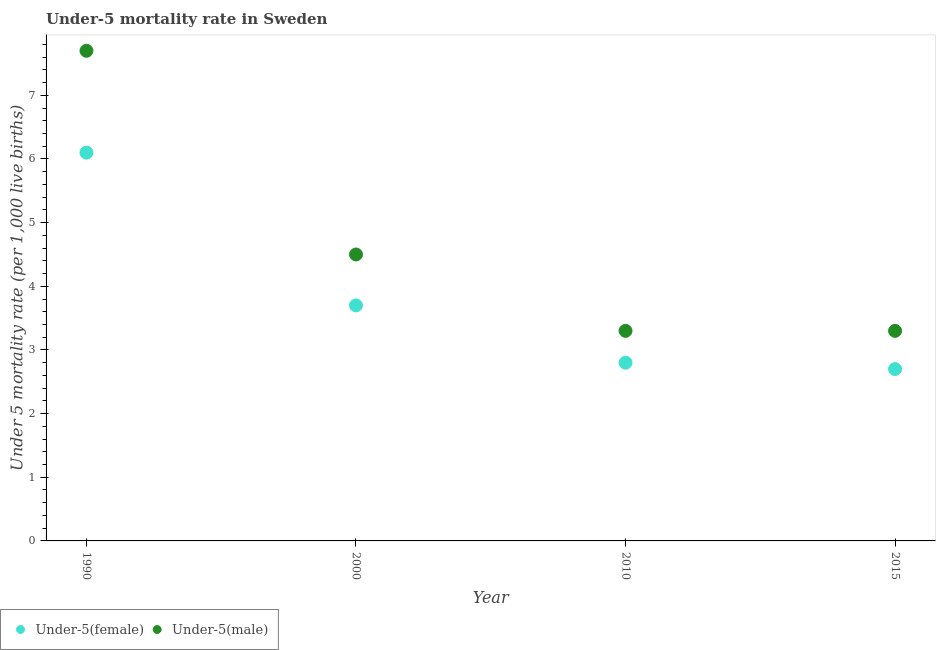Is the number of dotlines equal to the number of legend labels?
Offer a very short reply. Yes. What is the under-5 male mortality rate in 2010?
Provide a succinct answer. 3.3. In which year was the under-5 female mortality rate minimum?
Give a very brief answer. 2015. What is the total under-5 male mortality rate in the graph?
Make the answer very short. 18.8. What is the difference between the under-5 female mortality rate in 2000 and that in 2015?
Give a very brief answer. 1. What is the difference between the under-5 female mortality rate in 2010 and the under-5 male mortality rate in 2015?
Your answer should be compact. -0.5. In the year 2010, what is the difference between the under-5 male mortality rate and under-5 female mortality rate?
Offer a terse response. 0.5. In how many years, is the under-5 female mortality rate greater than 5.8?
Provide a short and direct response. 1. What is the ratio of the under-5 male mortality rate in 1990 to that in 2000?
Make the answer very short. 1.71. Is the under-5 female mortality rate in 2000 less than that in 2015?
Your answer should be compact. No. Is the difference between the under-5 female mortality rate in 2010 and 2015 greater than the difference between the under-5 male mortality rate in 2010 and 2015?
Your answer should be very brief. Yes. What is the difference between the highest and the second highest under-5 male mortality rate?
Your response must be concise. 3.2. What is the difference between the highest and the lowest under-5 female mortality rate?
Give a very brief answer. 3.4. Is the sum of the under-5 male mortality rate in 2000 and 2015 greater than the maximum under-5 female mortality rate across all years?
Your answer should be very brief. Yes. Is the under-5 male mortality rate strictly greater than the under-5 female mortality rate over the years?
Offer a very short reply. Yes. How many dotlines are there?
Offer a very short reply. 2. Does the graph contain any zero values?
Your answer should be compact. No. Does the graph contain grids?
Your answer should be very brief. No. Where does the legend appear in the graph?
Provide a succinct answer. Bottom left. How are the legend labels stacked?
Your answer should be very brief. Horizontal. What is the title of the graph?
Ensure brevity in your answer.  Under-5 mortality rate in Sweden. Does "Excluding technical cooperation" appear as one of the legend labels in the graph?
Ensure brevity in your answer.  No. What is the label or title of the X-axis?
Offer a very short reply. Year. What is the label or title of the Y-axis?
Provide a short and direct response. Under 5 mortality rate (per 1,0 live births). What is the Under 5 mortality rate (per 1,000 live births) in Under-5(female) in 1990?
Give a very brief answer. 6.1. What is the Under 5 mortality rate (per 1,000 live births) in Under-5(female) in 2000?
Offer a very short reply. 3.7. What is the Under 5 mortality rate (per 1,000 live births) in Under-5(male) in 2010?
Provide a succinct answer. 3.3. Across all years, what is the maximum Under 5 mortality rate (per 1,000 live births) in Under-5(female)?
Your answer should be compact. 6.1. What is the difference between the Under 5 mortality rate (per 1,000 live births) in Under-5(female) in 1990 and that in 2010?
Give a very brief answer. 3.3. What is the difference between the Under 5 mortality rate (per 1,000 live births) of Under-5(female) in 1990 and that in 2015?
Provide a short and direct response. 3.4. What is the difference between the Under 5 mortality rate (per 1,000 live births) in Under-5(male) in 2000 and that in 2010?
Offer a very short reply. 1.2. What is the difference between the Under 5 mortality rate (per 1,000 live births) of Under-5(female) in 2000 and that in 2015?
Your answer should be compact. 1. What is the difference between the Under 5 mortality rate (per 1,000 live births) of Under-5(female) in 2000 and the Under 5 mortality rate (per 1,000 live births) of Under-5(male) in 2010?
Provide a succinct answer. 0.4. What is the difference between the Under 5 mortality rate (per 1,000 live births) of Under-5(female) in 2010 and the Under 5 mortality rate (per 1,000 live births) of Under-5(male) in 2015?
Your answer should be compact. -0.5. What is the average Under 5 mortality rate (per 1,000 live births) in Under-5(female) per year?
Offer a very short reply. 3.83. What is the average Under 5 mortality rate (per 1,000 live births) in Under-5(male) per year?
Your answer should be compact. 4.7. In the year 1990, what is the difference between the Under 5 mortality rate (per 1,000 live births) in Under-5(female) and Under 5 mortality rate (per 1,000 live births) in Under-5(male)?
Provide a succinct answer. -1.6. In the year 2010, what is the difference between the Under 5 mortality rate (per 1,000 live births) of Under-5(female) and Under 5 mortality rate (per 1,000 live births) of Under-5(male)?
Your answer should be compact. -0.5. In the year 2015, what is the difference between the Under 5 mortality rate (per 1,000 live births) of Under-5(female) and Under 5 mortality rate (per 1,000 live births) of Under-5(male)?
Keep it short and to the point. -0.6. What is the ratio of the Under 5 mortality rate (per 1,000 live births) in Under-5(female) in 1990 to that in 2000?
Provide a short and direct response. 1.65. What is the ratio of the Under 5 mortality rate (per 1,000 live births) of Under-5(male) in 1990 to that in 2000?
Your response must be concise. 1.71. What is the ratio of the Under 5 mortality rate (per 1,000 live births) of Under-5(female) in 1990 to that in 2010?
Provide a short and direct response. 2.18. What is the ratio of the Under 5 mortality rate (per 1,000 live births) of Under-5(male) in 1990 to that in 2010?
Make the answer very short. 2.33. What is the ratio of the Under 5 mortality rate (per 1,000 live births) of Under-5(female) in 1990 to that in 2015?
Your answer should be very brief. 2.26. What is the ratio of the Under 5 mortality rate (per 1,000 live births) in Under-5(male) in 1990 to that in 2015?
Your answer should be compact. 2.33. What is the ratio of the Under 5 mortality rate (per 1,000 live births) in Under-5(female) in 2000 to that in 2010?
Ensure brevity in your answer.  1.32. What is the ratio of the Under 5 mortality rate (per 1,000 live births) of Under-5(male) in 2000 to that in 2010?
Ensure brevity in your answer.  1.36. What is the ratio of the Under 5 mortality rate (per 1,000 live births) of Under-5(female) in 2000 to that in 2015?
Make the answer very short. 1.37. What is the ratio of the Under 5 mortality rate (per 1,000 live births) of Under-5(male) in 2000 to that in 2015?
Offer a very short reply. 1.36. What is the ratio of the Under 5 mortality rate (per 1,000 live births) in Under-5(female) in 2010 to that in 2015?
Offer a very short reply. 1.04. What is the ratio of the Under 5 mortality rate (per 1,000 live births) of Under-5(male) in 2010 to that in 2015?
Your answer should be compact. 1. What is the difference between the highest and the second highest Under 5 mortality rate (per 1,000 live births) in Under-5(male)?
Your response must be concise. 3.2. What is the difference between the highest and the lowest Under 5 mortality rate (per 1,000 live births) in Under-5(female)?
Your answer should be very brief. 3.4. What is the difference between the highest and the lowest Under 5 mortality rate (per 1,000 live births) of Under-5(male)?
Give a very brief answer. 4.4. 